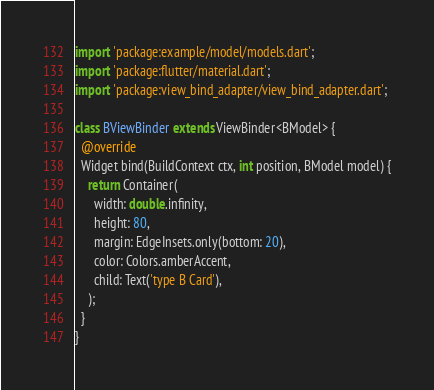Convert code to text. <code><loc_0><loc_0><loc_500><loc_500><_Dart_>import 'package:example/model/models.dart';
import 'package:flutter/material.dart';
import 'package:view_bind_adapter/view_bind_adapter.dart';

class BViewBinder extends ViewBinder<BModel> {
  @override
  Widget bind(BuildContext ctx, int position, BModel model) {
    return Container(
      width: double.infinity,
      height: 80,
      margin: EdgeInsets.only(bottom: 20),
      color: Colors.amberAccent,
      child: Text('type B Card'),
    );
  }
}
</code> 